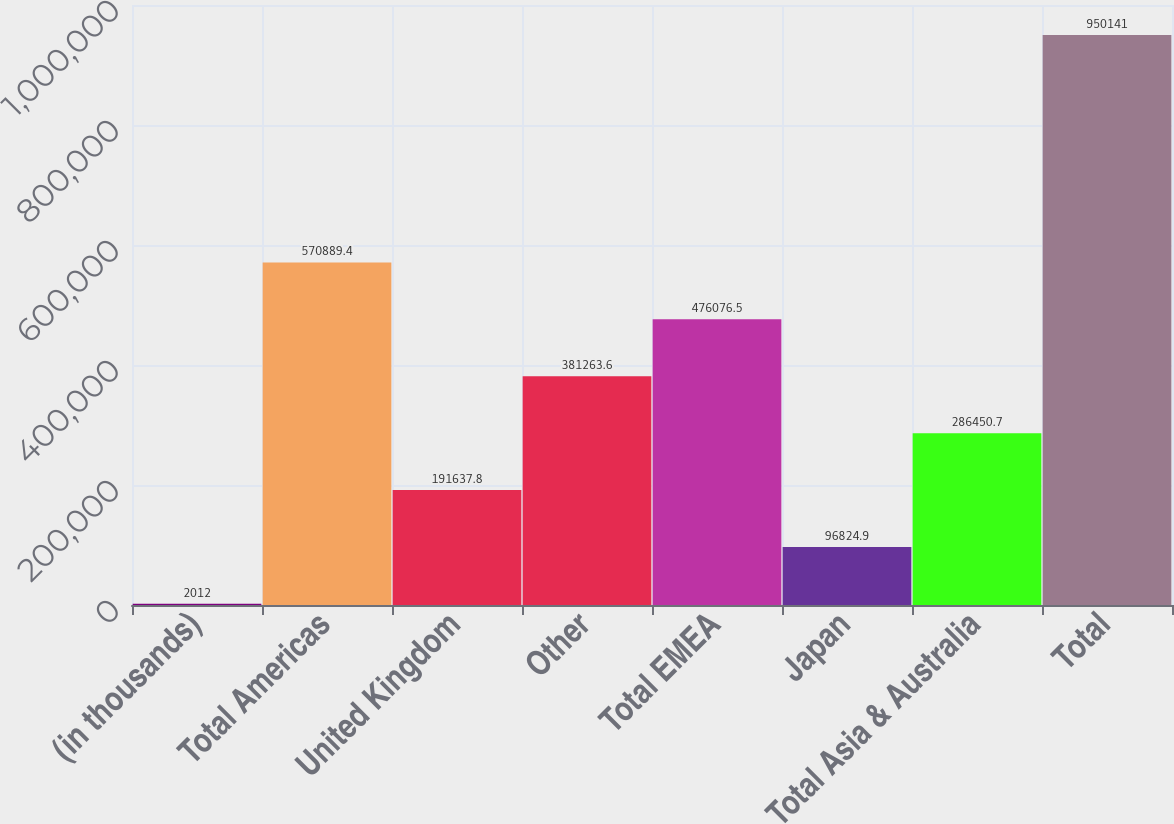Convert chart. <chart><loc_0><loc_0><loc_500><loc_500><bar_chart><fcel>(in thousands)<fcel>Total Americas<fcel>United Kingdom<fcel>Other<fcel>Total EMEA<fcel>Japan<fcel>Total Asia & Australia<fcel>Total<nl><fcel>2012<fcel>570889<fcel>191638<fcel>381264<fcel>476076<fcel>96824.9<fcel>286451<fcel>950141<nl></chart> 